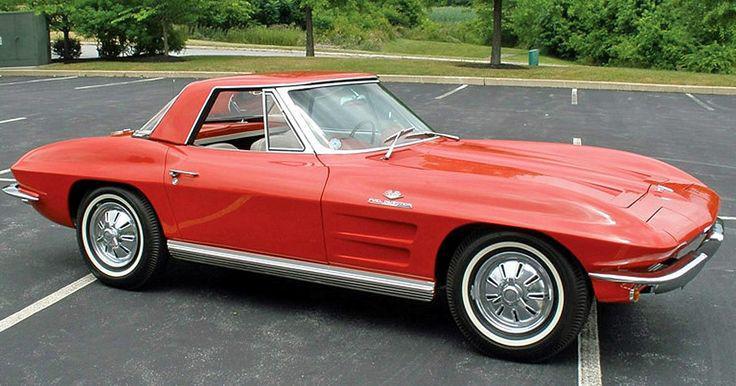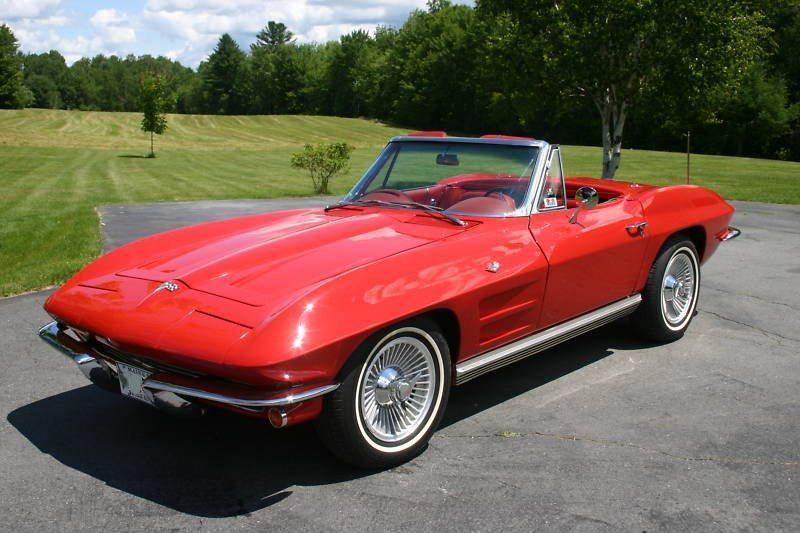The first image is the image on the left, the second image is the image on the right. For the images shown, is this caption "One of the corvettes is on the road." true? Answer yes or no. No. 